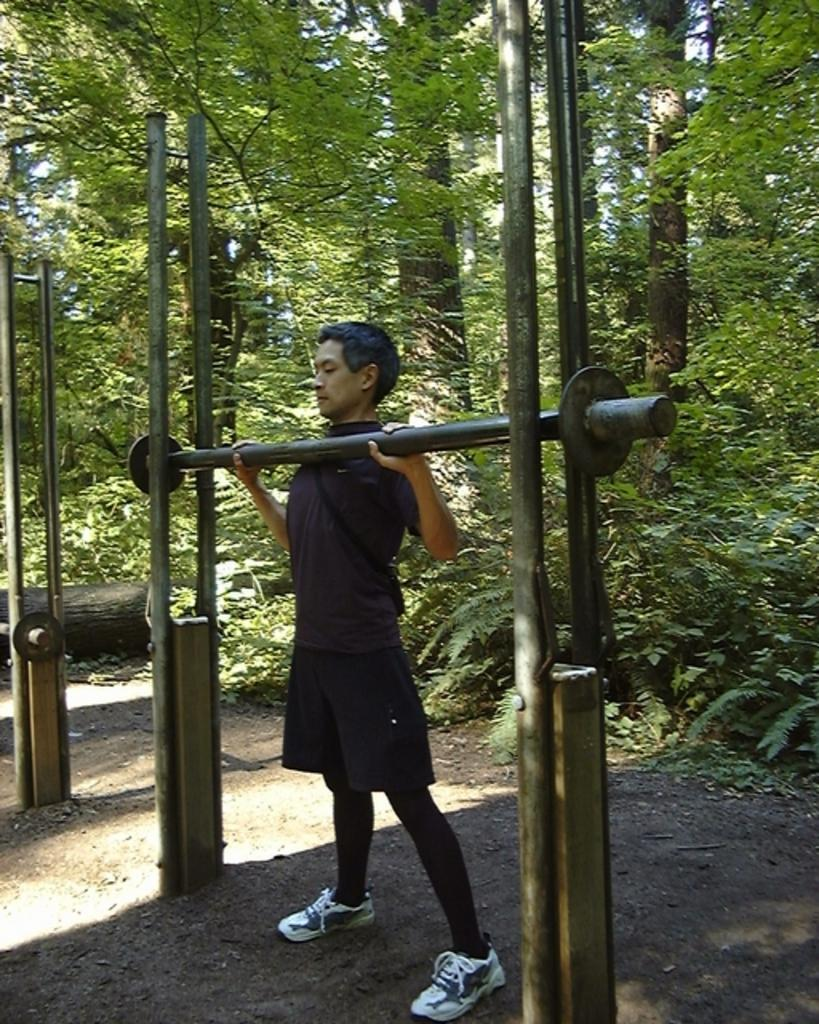What is the person in the image doing? The person is holding a weight lifting rod. What objects are on the ground in the image? Weights are on the ground. Are there any other rods or equipment visible in the image? Yes, there are additional rods on the side. What can be seen in the background of the image? Trees are visible in the background of the image. What type of seed is the person planting in the image? There is no seed or planting activity present in the image; the person is holding a weight lifting rod. Can you hear the person crying in the image? There is no sound or indication of crying in the image. 